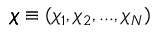Convert formula to latex. <formula><loc_0><loc_0><loc_500><loc_500>\pm b { \chi } \equiv ( \chi _ { 1 } , \chi _ { 2 } , \dots , \chi _ { N } )</formula> 